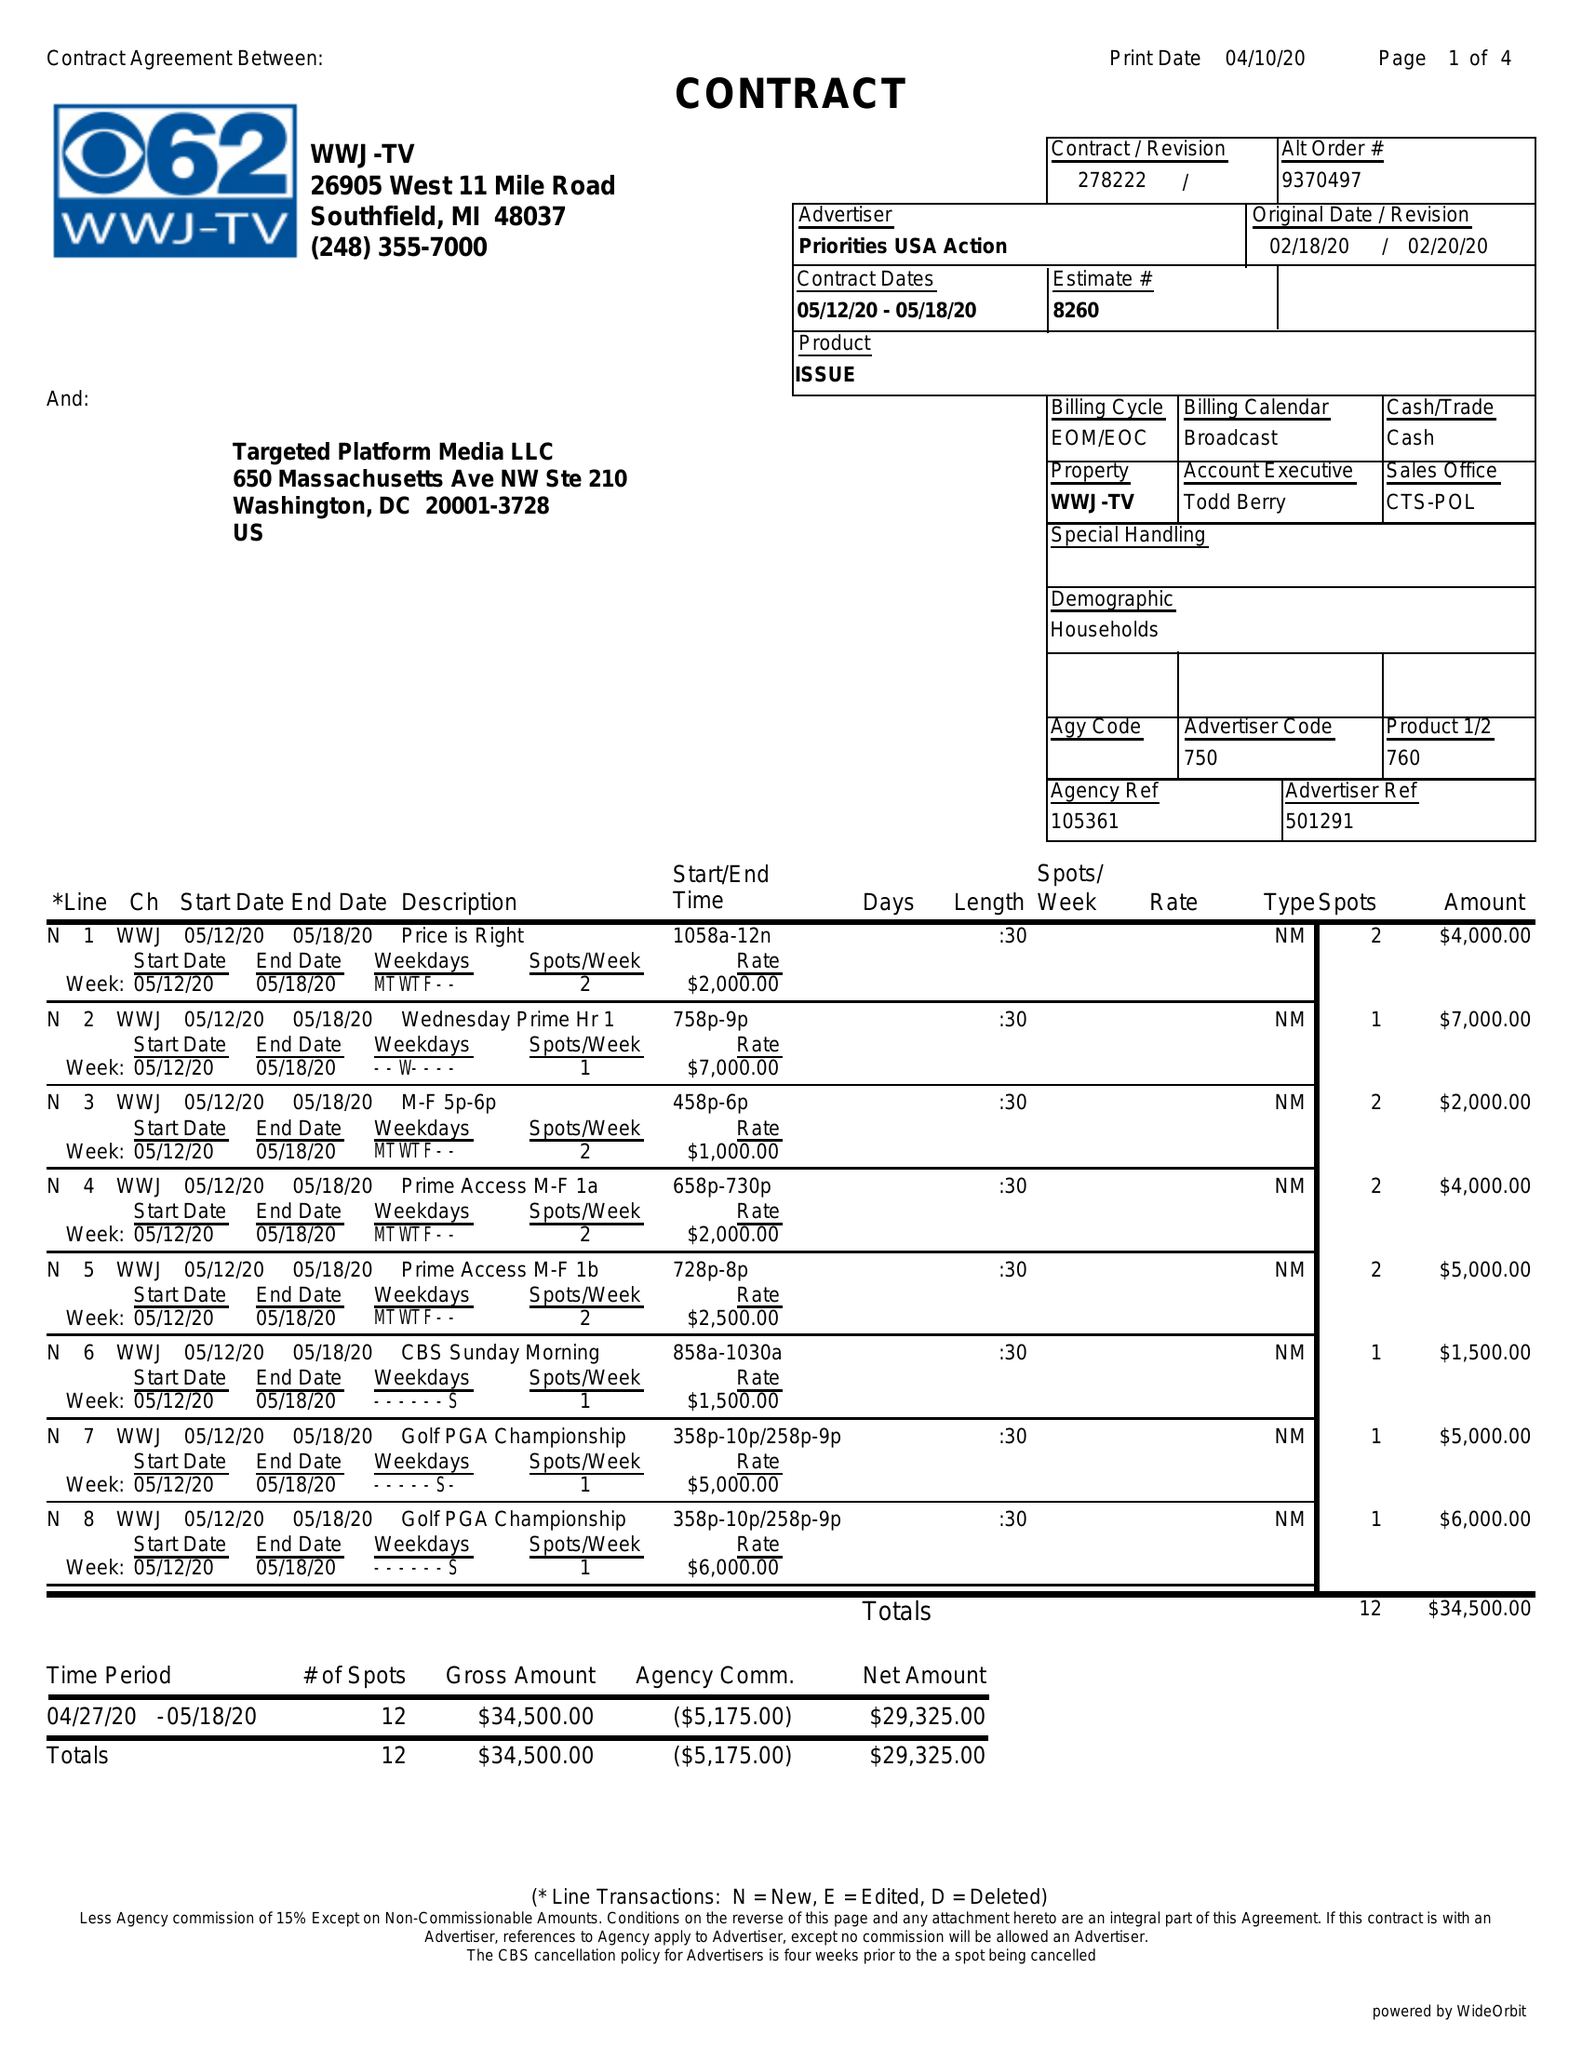What is the value for the flight_from?
Answer the question using a single word or phrase. 05/12/20 